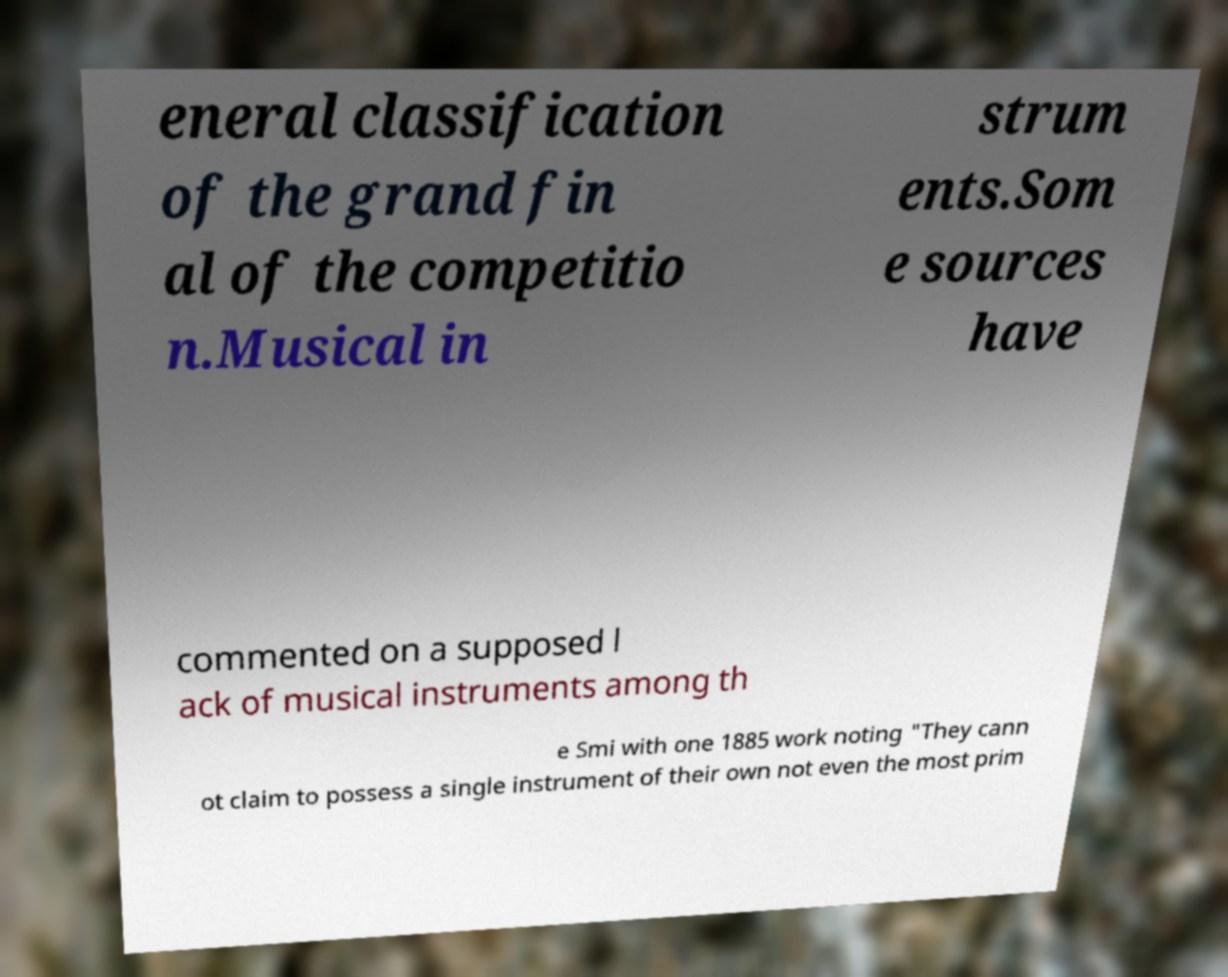Could you assist in decoding the text presented in this image and type it out clearly? eneral classification of the grand fin al of the competitio n.Musical in strum ents.Som e sources have commented on a supposed l ack of musical instruments among th e Smi with one 1885 work noting "They cann ot claim to possess a single instrument of their own not even the most prim 